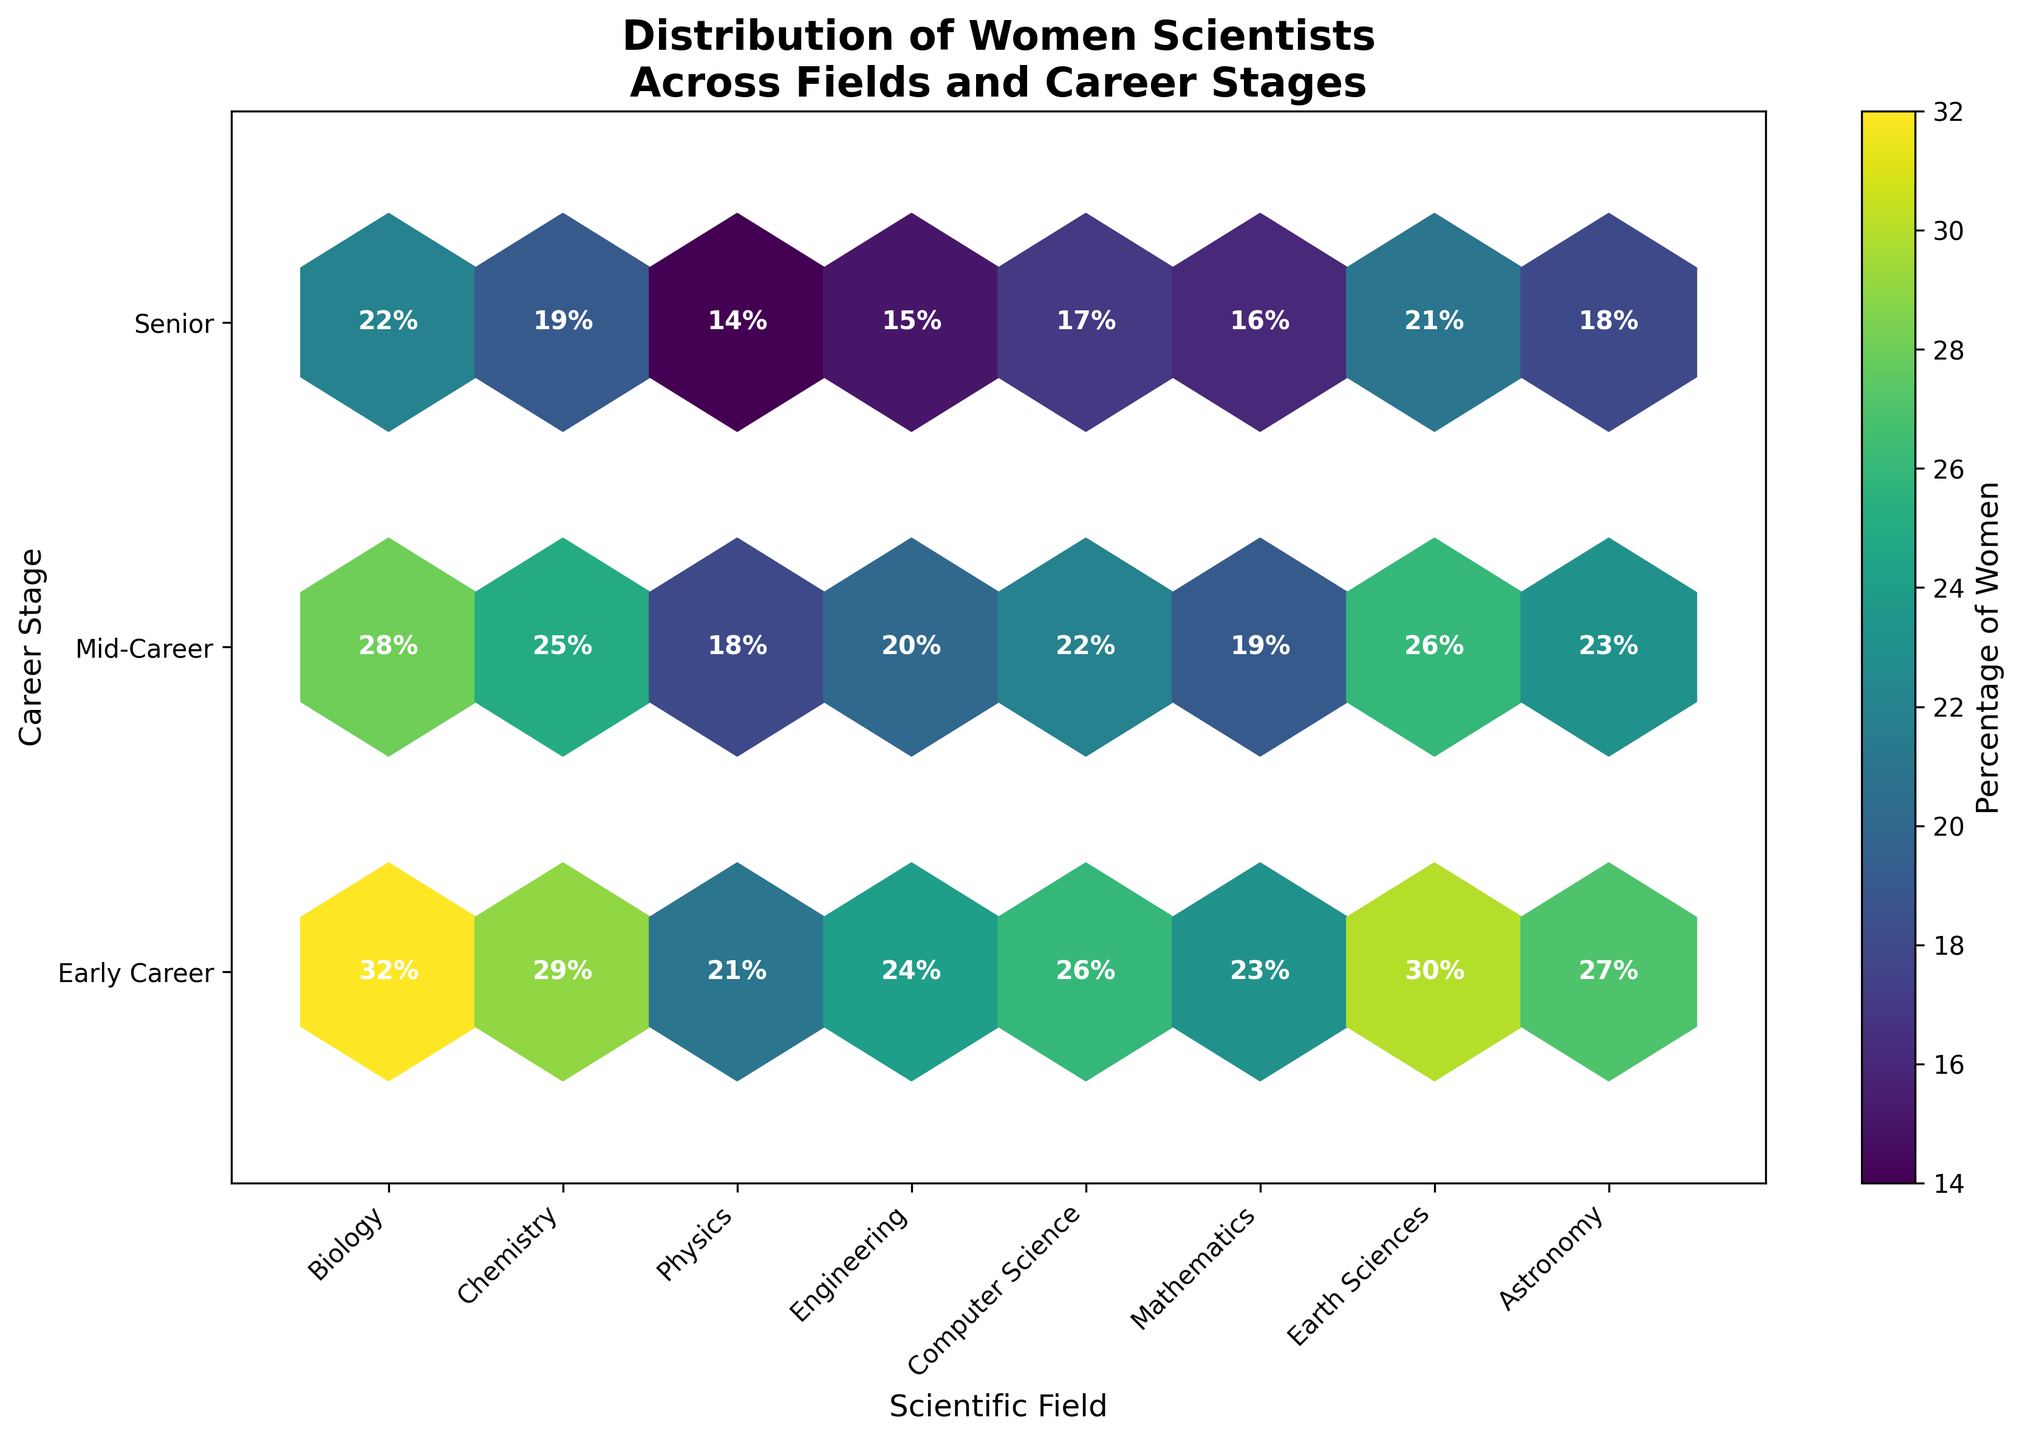What is the title of the plot? The title is usually located at the top of the plot and is in a larger and bold font style. It provides a general description of what the plot represents.
Answer: Distribution of Women Scientists Across Fields and Career Stages Which scientific field has the highest percentage of women in the senior career stage? Identify the column for the senior career stage and then look for the maximum value. In this case, the highest percentage is highlighted by a more intense color and, additionally, the values are annotated.
Answer: Biology Which career stage generally has the highest percentages of women across most scientific fields? Compare the overall intensity of colors across all fields for each career stage. The stage with more intense colors (higher percentages) would stand out.
Answer: Early Career What is the percentage of women in the mid-career stage in the field of Chemistry? Locate the intersection of Chemistry in the x-axis and Mid-Career in the y-axis. The plot provides the exact annotated percentage within the hexbin.
Answer: 25% Compare the representation of women in the early career stage between Earth Sciences and Physics. Which field has a higher percentage, and by how much? Find the annotated percentage for the early career stage of Earth Sciences and Physics, then perform the subtraction for comparison.
Answer: Earth Sciences has 9% more than Physics (30% - 21%) What is the average percentage of women in the senior career stage for all fields? Sum the percentages of women in the senior career stage across all fields and then divide by the number of fields.
Answer: (22 + 19 + 14 + 15 + 17 + 16 + 21 + 18) / 8 = 17.75% Which scientific field shows the lowest percentage of women in the early career stage? Identify the column for the early career stage and find the minimum value across all fields. The field that corresponds with this value shows the lowest percentage.
Answer: Physics What is the color scheme used in the plot? The color scheme helps to differentiate the data points based on their value. In this plot, a specific colormap is used.
Answer: Viridis Explain the relationship between career stage and the percentage of women across most fields. By observing the colors moving from left to right (early to senior), it is visible that there is usually a decrease in the percentage of women as the career stage advances. This trend is visible due to the lowering of color intensity and annotated values.
Answer: As career stage advances, the percentage of women generally decreases 